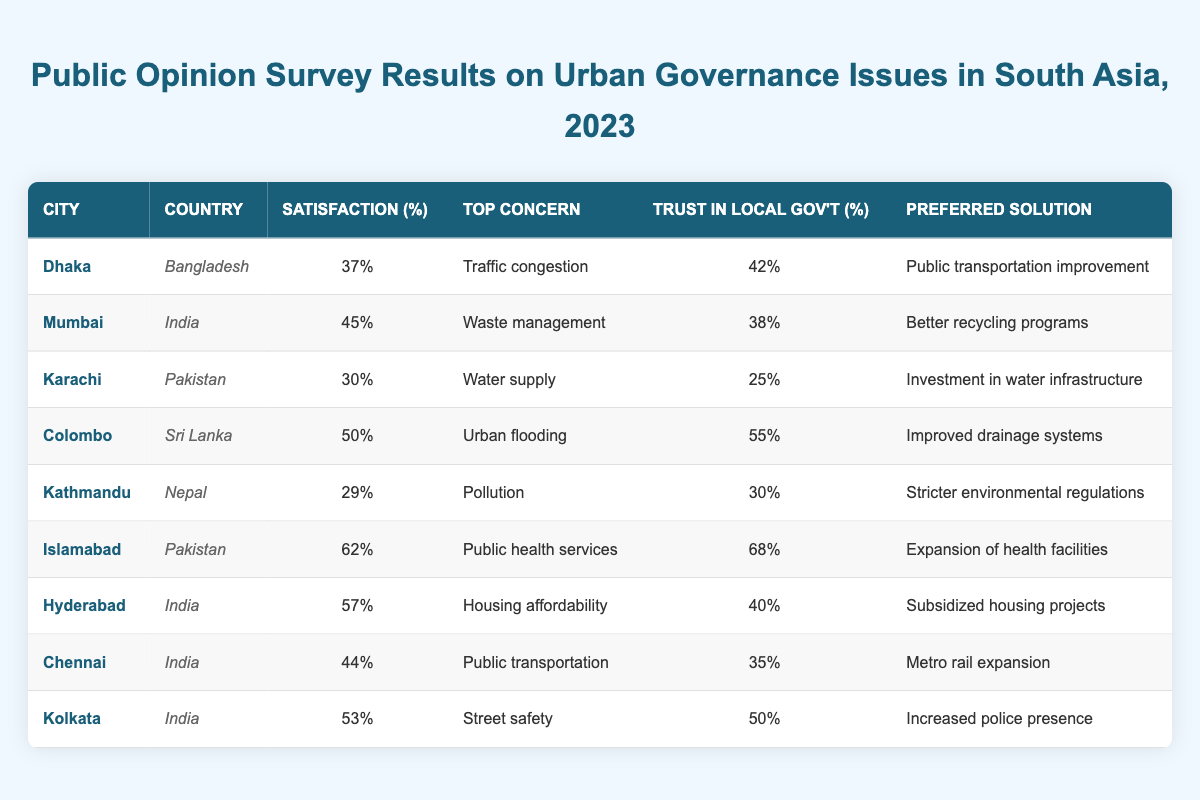What is the top concern for residents in Dhaka? The table lists the top concern for each city, and for Dhaka, it is "Traffic congestion."
Answer: Traffic congestion Which city has the highest percentage of satisfaction with governance? By examining the satisfaction percentages for each city, Islamabad has the highest at 62%.
Answer: 62% What is the preferred solution for waste management in Mumbai? The table shows that the preferred solution for waste management in Mumbai is "Better recycling programs."
Answer: Better recycling programs Is the trust in local government higher in Colombo or Mumbai? The trust percentages in the table indicate Colombo has 55% and Mumbai has 38%, which means trust is higher in Colombo.
Answer: Colombo What is the average percentage of satisfaction with governance across all cities? To calculate the average, we sum the percentages: (37 + 45 + 30 + 50 + 29 + 62 + 57 + 44 + 53) = 407 and divide by 9 cities. This results in an average of approximately 45.22%.
Answer: 45.22% In which city do residents have the least trust in local government, and what is that percentage? By reviewing the trust percentages, Karachi has the lowest at 25%.
Answer: Karachi, 25% What is the difference in satisfaction percentage between Islamabad and Karachi? The satisfaction percentage for Islamabad is 62% and for Karachi it is 30%. The difference is 62 - 30 = 32%.
Answer: 32% Which city has the highest trust in local government and what is the percentage? The table shows Islamabad has the highest trust in local government at 68%.
Answer: Islamabad, 68% How many cities report pollution as a top concern? The table shows that only Kathmandu lists pollution as the top concern, so there is one city.
Answer: 1 What relationship can be seen between the top concerns and the preferred solutions in the cities? Analyzing the data shows that each city's top concern is addressed by its preferred solution, indicating residents prioritize related issues.
Answer: Related issues are prioritized 